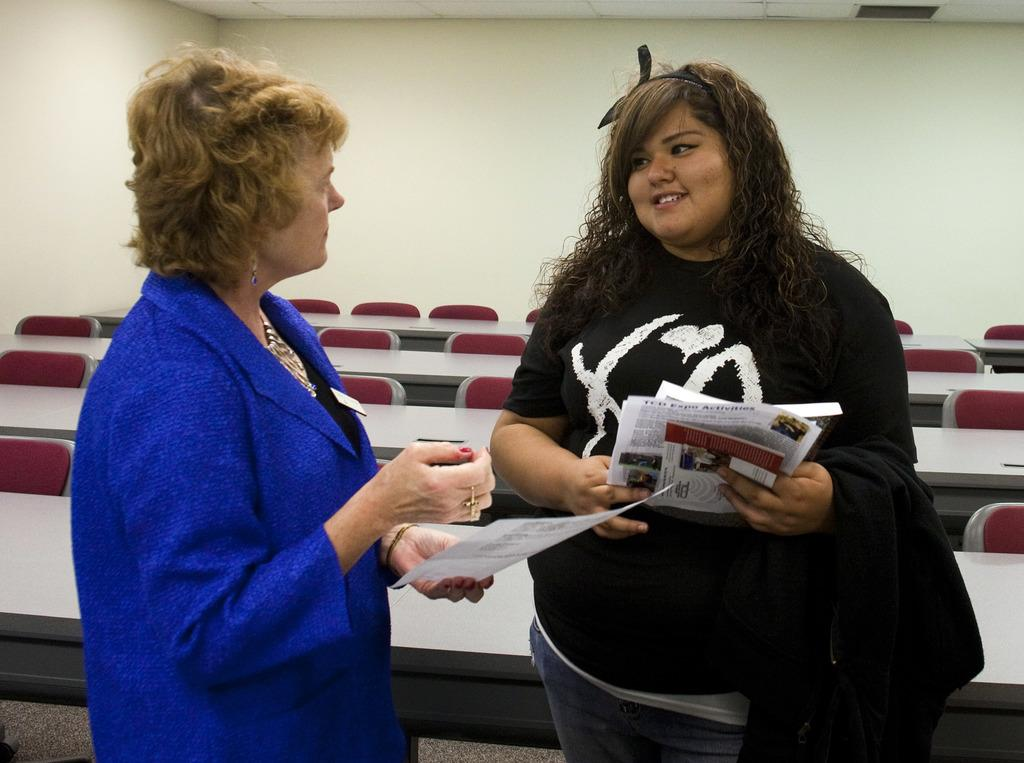How many people are in the image? There are two people in the image. What are the people holding in the image? The people are holding papers. What type of furniture is present in the image? There are tables and chairs in the image. What can be seen on the background of the image? There is a wall visible in the image. How many toes can be seen on the women in the image? There are no women present in the image, so it is not possible to determine the number of toes visible. 